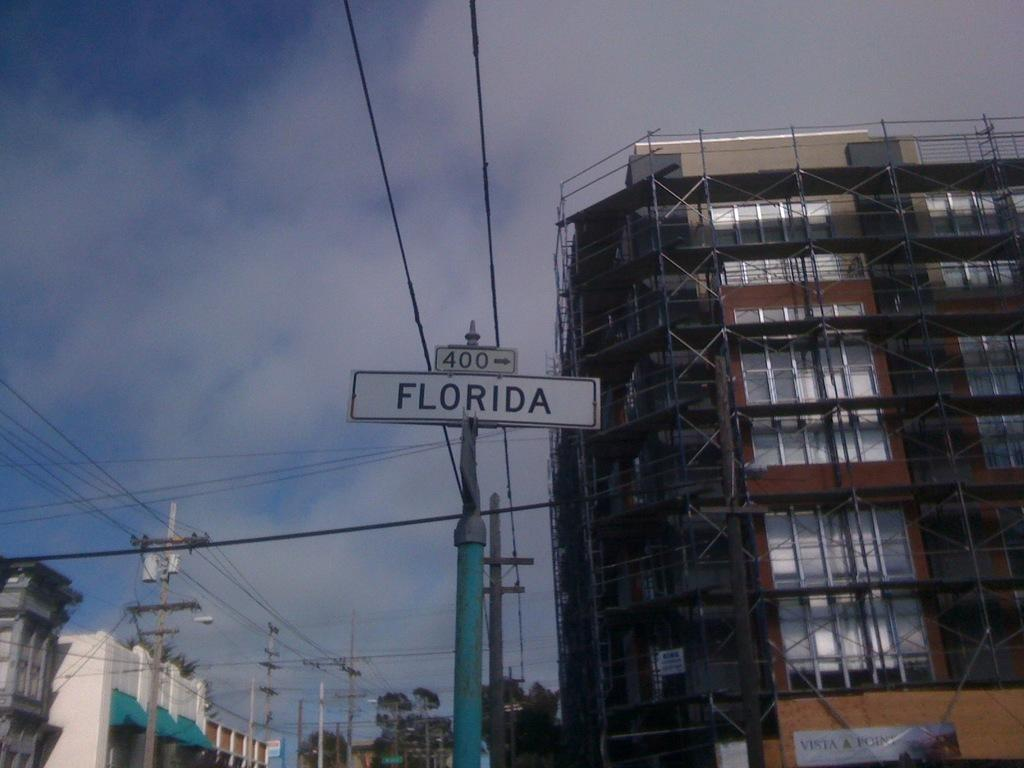What type of structures can be seen in the image? There are buildings in the image. What objects are located in the middle of the image? There are poles and a board along with wires in the middle of the image. What is visible at the top of the image? There are clouds visible at the top of the image. Can you describe the circle of friends gathered around the board in the image? There is no circle of friends or any people present in the image. The image only features buildings, poles, a board with wires, and clouds. 